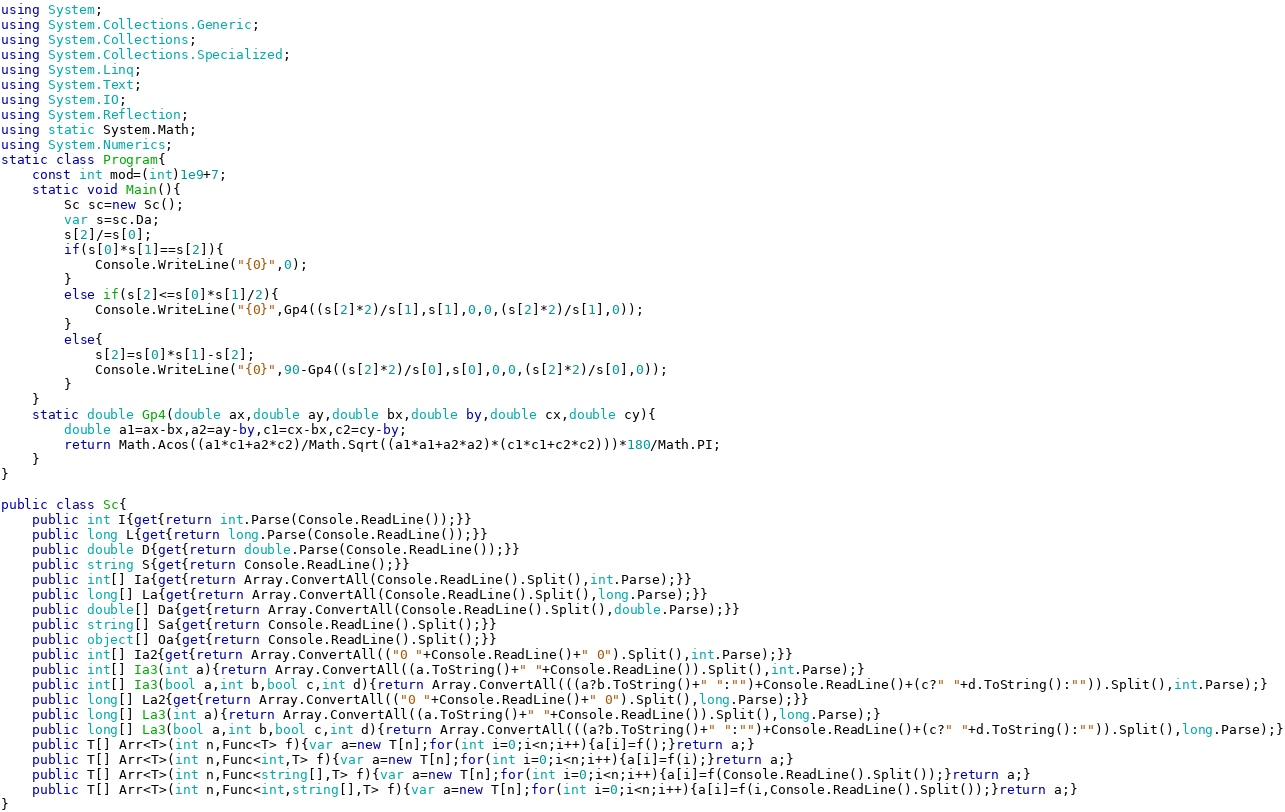<code> <loc_0><loc_0><loc_500><loc_500><_C#_>using System;
using System.Collections.Generic;
using System.Collections;
using System.Collections.Specialized;
using System.Linq;
using System.Text;
using System.IO;
using System.Reflection;
using static System.Math;
using System.Numerics;
static class Program{
	const int mod=(int)1e9+7;
	static void Main(){
		Sc sc=new Sc();
		var s=sc.Da;
		s[2]/=s[0];
		if(s[0]*s[1]==s[2]){
			Console.WriteLine("{0}",0);
		}
		else if(s[2]<=s[0]*s[1]/2){
			Console.WriteLine("{0}",Gp4((s[2]*2)/s[1],s[1],0,0,(s[2]*2)/s[1],0));
		}
		else{
			s[2]=s[0]*s[1]-s[2];
			Console.WriteLine("{0}",90-Gp4((s[2]*2)/s[0],s[0],0,0,(s[2]*2)/s[0],0));
		}
	}
	static double Gp4(double ax,double ay,double bx,double by,double cx,double cy){
		double a1=ax-bx,a2=ay-by,c1=cx-bx,c2=cy-by;
		return Math.Acos((a1*c1+a2*c2)/Math.Sqrt((a1*a1+a2*a2)*(c1*c1+c2*c2)))*180/Math.PI;
	}
}

public class Sc{
	public int I{get{return int.Parse(Console.ReadLine());}}
	public long L{get{return long.Parse(Console.ReadLine());}}
	public double D{get{return double.Parse(Console.ReadLine());}}
	public string S{get{return Console.ReadLine();}}
	public int[] Ia{get{return Array.ConvertAll(Console.ReadLine().Split(),int.Parse);}}
	public long[] La{get{return Array.ConvertAll(Console.ReadLine().Split(),long.Parse);}}
	public double[] Da{get{return Array.ConvertAll(Console.ReadLine().Split(),double.Parse);}}
	public string[] Sa{get{return Console.ReadLine().Split();}}
	public object[] Oa{get{return Console.ReadLine().Split();}}
	public int[] Ia2{get{return Array.ConvertAll(("0 "+Console.ReadLine()+" 0").Split(),int.Parse);}}
	public int[] Ia3(int a){return Array.ConvertAll((a.ToString()+" "+Console.ReadLine()).Split(),int.Parse);}
	public int[] Ia3(bool a,int b,bool c,int d){return Array.ConvertAll(((a?b.ToString()+" ":"")+Console.ReadLine()+(c?" "+d.ToString():"")).Split(),int.Parse);}
	public long[] La2{get{return Array.ConvertAll(("0 "+Console.ReadLine()+" 0").Split(),long.Parse);}}
	public long[] La3(int a){return Array.ConvertAll((a.ToString()+" "+Console.ReadLine()).Split(),long.Parse);}
	public long[] La3(bool a,int b,bool c,int d){return Array.ConvertAll(((a?b.ToString()+" ":"")+Console.ReadLine()+(c?" "+d.ToString():"")).Split(),long.Parse);}
	public T[] Arr<T>(int n,Func<T> f){var a=new T[n];for(int i=0;i<n;i++){a[i]=f();}return a;}
	public T[] Arr<T>(int n,Func<int,T> f){var a=new T[n];for(int i=0;i<n;i++){a[i]=f(i);}return a;}
	public T[] Arr<T>(int n,Func<string[],T> f){var a=new T[n];for(int i=0;i<n;i++){a[i]=f(Console.ReadLine().Split());}return a;}
	public T[] Arr<T>(int n,Func<int,string[],T> f){var a=new T[n];for(int i=0;i<n;i++){a[i]=f(i,Console.ReadLine().Split());}return a;}
}</code> 